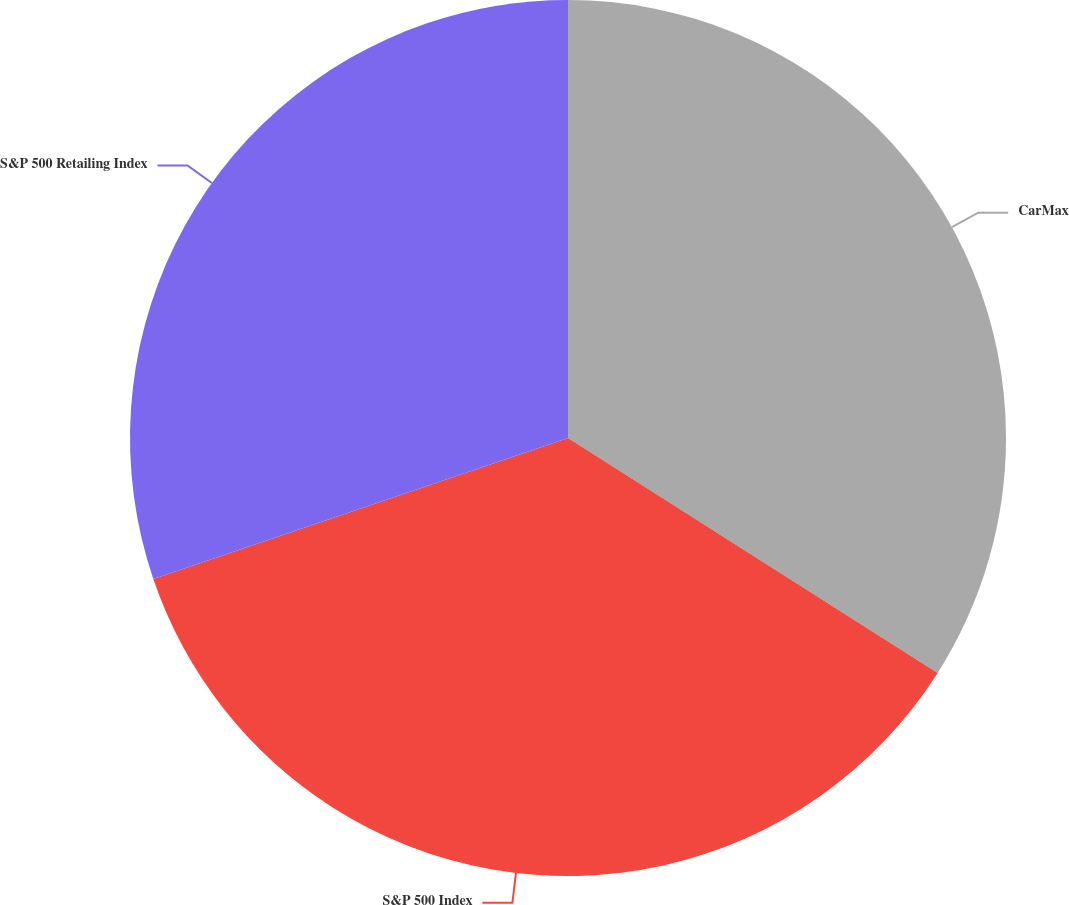<chart> <loc_0><loc_0><loc_500><loc_500><pie_chart><fcel>CarMax<fcel>S&P 500 Index<fcel>S&P 500 Retailing Index<nl><fcel>34.01%<fcel>35.77%<fcel>30.22%<nl></chart> 